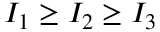Convert formula to latex. <formula><loc_0><loc_0><loc_500><loc_500>I _ { 1 } \geq I _ { 2 } \geq I _ { 3 }</formula> 